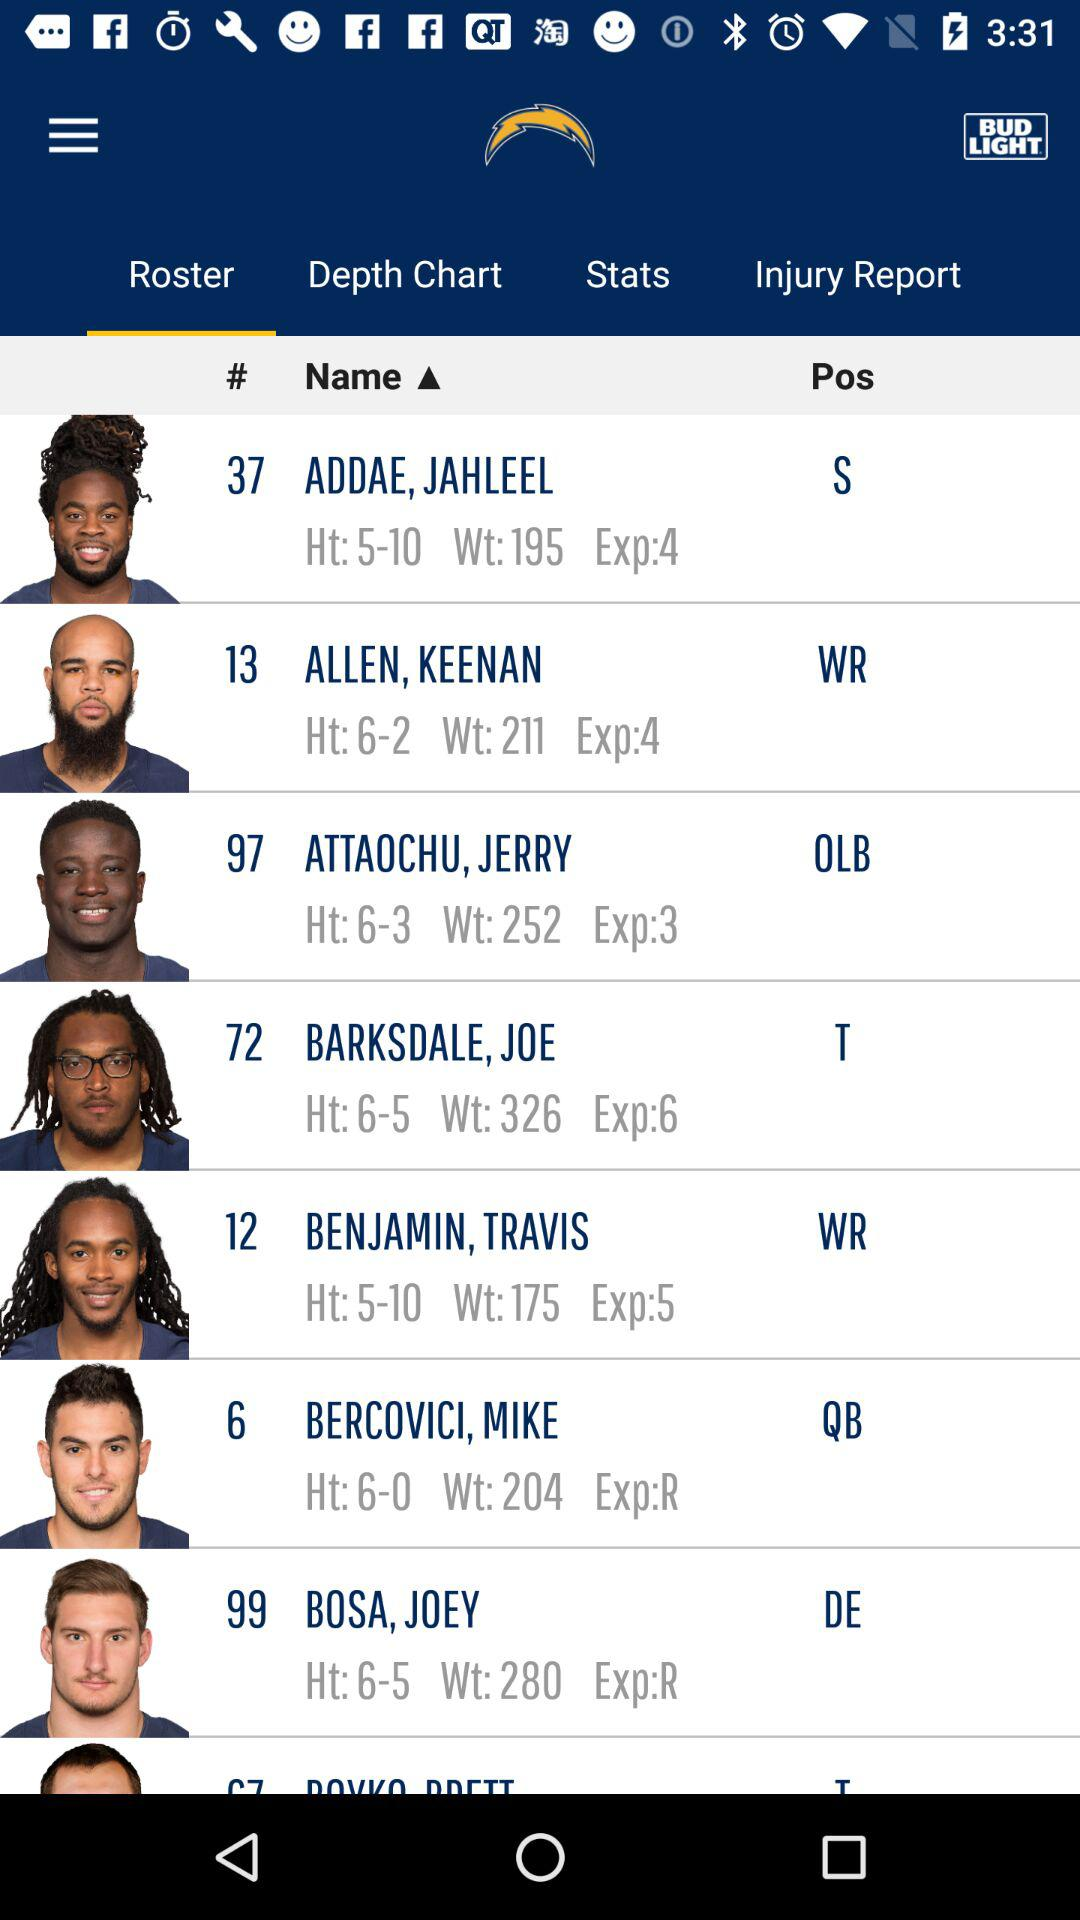Which tab is selected? The selected tab is "Roster". 